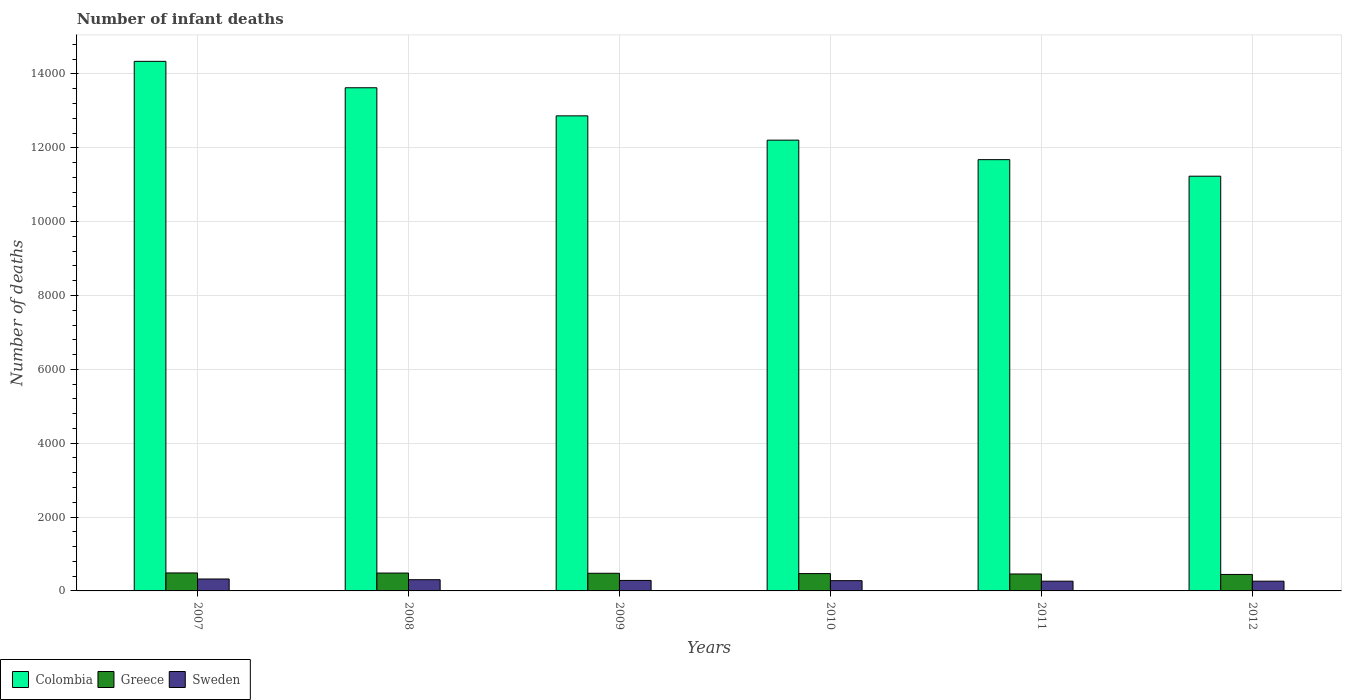What is the label of the 2nd group of bars from the left?
Keep it short and to the point. 2008. In how many cases, is the number of bars for a given year not equal to the number of legend labels?
Provide a succinct answer. 0. What is the number of infant deaths in Greece in 2009?
Ensure brevity in your answer.  478. Across all years, what is the maximum number of infant deaths in Greece?
Offer a very short reply. 487. Across all years, what is the minimum number of infant deaths in Sweden?
Ensure brevity in your answer.  264. What is the total number of infant deaths in Greece in the graph?
Offer a very short reply. 2823. What is the difference between the number of infant deaths in Greece in 2011 and that in 2012?
Keep it short and to the point. 13. What is the difference between the number of infant deaths in Sweden in 2008 and the number of infant deaths in Colombia in 2007?
Keep it short and to the point. -1.40e+04. What is the average number of infant deaths in Greece per year?
Offer a very short reply. 470.5. In the year 2007, what is the difference between the number of infant deaths in Sweden and number of infant deaths in Colombia?
Offer a very short reply. -1.40e+04. What is the ratio of the number of infant deaths in Colombia in 2008 to that in 2010?
Your answer should be compact. 1.12. What is the difference between the highest and the second highest number of infant deaths in Colombia?
Give a very brief answer. 715. What is the difference between the highest and the lowest number of infant deaths in Colombia?
Provide a short and direct response. 3110. In how many years, is the number of infant deaths in Colombia greater than the average number of infant deaths in Colombia taken over all years?
Make the answer very short. 3. What does the 3rd bar from the right in 2012 represents?
Offer a very short reply. Colombia. Is it the case that in every year, the sum of the number of infant deaths in Sweden and number of infant deaths in Greece is greater than the number of infant deaths in Colombia?
Make the answer very short. No. Are all the bars in the graph horizontal?
Ensure brevity in your answer.  No. How many years are there in the graph?
Keep it short and to the point. 6. What is the difference between two consecutive major ticks on the Y-axis?
Keep it short and to the point. 2000. How are the legend labels stacked?
Ensure brevity in your answer.  Horizontal. What is the title of the graph?
Offer a very short reply. Number of infant deaths. Does "Honduras" appear as one of the legend labels in the graph?
Your answer should be very brief. No. What is the label or title of the X-axis?
Ensure brevity in your answer.  Years. What is the label or title of the Y-axis?
Keep it short and to the point. Number of deaths. What is the Number of deaths of Colombia in 2007?
Your response must be concise. 1.43e+04. What is the Number of deaths of Greece in 2007?
Your response must be concise. 487. What is the Number of deaths of Sweden in 2007?
Offer a very short reply. 323. What is the Number of deaths in Colombia in 2008?
Your response must be concise. 1.36e+04. What is the Number of deaths in Greece in 2008?
Give a very brief answer. 484. What is the Number of deaths of Sweden in 2008?
Keep it short and to the point. 304. What is the Number of deaths in Colombia in 2009?
Ensure brevity in your answer.  1.29e+04. What is the Number of deaths in Greece in 2009?
Your response must be concise. 478. What is the Number of deaths in Sweden in 2009?
Your response must be concise. 284. What is the Number of deaths of Colombia in 2010?
Ensure brevity in your answer.  1.22e+04. What is the Number of deaths in Greece in 2010?
Offer a terse response. 469. What is the Number of deaths in Sweden in 2010?
Offer a terse response. 278. What is the Number of deaths in Colombia in 2011?
Offer a very short reply. 1.17e+04. What is the Number of deaths in Greece in 2011?
Keep it short and to the point. 459. What is the Number of deaths of Sweden in 2011?
Your answer should be compact. 264. What is the Number of deaths of Colombia in 2012?
Provide a succinct answer. 1.12e+04. What is the Number of deaths in Greece in 2012?
Your answer should be compact. 446. What is the Number of deaths in Sweden in 2012?
Offer a very short reply. 264. Across all years, what is the maximum Number of deaths of Colombia?
Your answer should be compact. 1.43e+04. Across all years, what is the maximum Number of deaths in Greece?
Make the answer very short. 487. Across all years, what is the maximum Number of deaths in Sweden?
Provide a succinct answer. 323. Across all years, what is the minimum Number of deaths of Colombia?
Provide a succinct answer. 1.12e+04. Across all years, what is the minimum Number of deaths in Greece?
Make the answer very short. 446. Across all years, what is the minimum Number of deaths in Sweden?
Ensure brevity in your answer.  264. What is the total Number of deaths of Colombia in the graph?
Your answer should be compact. 7.60e+04. What is the total Number of deaths in Greece in the graph?
Keep it short and to the point. 2823. What is the total Number of deaths of Sweden in the graph?
Your response must be concise. 1717. What is the difference between the Number of deaths of Colombia in 2007 and that in 2008?
Provide a short and direct response. 715. What is the difference between the Number of deaths in Sweden in 2007 and that in 2008?
Ensure brevity in your answer.  19. What is the difference between the Number of deaths in Colombia in 2007 and that in 2009?
Provide a succinct answer. 1476. What is the difference between the Number of deaths in Colombia in 2007 and that in 2010?
Your answer should be very brief. 2134. What is the difference between the Number of deaths in Colombia in 2007 and that in 2011?
Make the answer very short. 2662. What is the difference between the Number of deaths in Greece in 2007 and that in 2011?
Your response must be concise. 28. What is the difference between the Number of deaths of Colombia in 2007 and that in 2012?
Offer a terse response. 3110. What is the difference between the Number of deaths in Sweden in 2007 and that in 2012?
Your answer should be very brief. 59. What is the difference between the Number of deaths in Colombia in 2008 and that in 2009?
Keep it short and to the point. 761. What is the difference between the Number of deaths in Sweden in 2008 and that in 2009?
Make the answer very short. 20. What is the difference between the Number of deaths in Colombia in 2008 and that in 2010?
Give a very brief answer. 1419. What is the difference between the Number of deaths of Colombia in 2008 and that in 2011?
Offer a very short reply. 1947. What is the difference between the Number of deaths in Greece in 2008 and that in 2011?
Provide a succinct answer. 25. What is the difference between the Number of deaths in Colombia in 2008 and that in 2012?
Offer a terse response. 2395. What is the difference between the Number of deaths in Greece in 2008 and that in 2012?
Your answer should be very brief. 38. What is the difference between the Number of deaths of Colombia in 2009 and that in 2010?
Give a very brief answer. 658. What is the difference between the Number of deaths of Colombia in 2009 and that in 2011?
Keep it short and to the point. 1186. What is the difference between the Number of deaths in Colombia in 2009 and that in 2012?
Offer a very short reply. 1634. What is the difference between the Number of deaths of Greece in 2009 and that in 2012?
Your answer should be compact. 32. What is the difference between the Number of deaths in Colombia in 2010 and that in 2011?
Your answer should be very brief. 528. What is the difference between the Number of deaths in Colombia in 2010 and that in 2012?
Your answer should be compact. 976. What is the difference between the Number of deaths in Sweden in 2010 and that in 2012?
Your answer should be very brief. 14. What is the difference between the Number of deaths of Colombia in 2011 and that in 2012?
Give a very brief answer. 448. What is the difference between the Number of deaths of Greece in 2011 and that in 2012?
Ensure brevity in your answer.  13. What is the difference between the Number of deaths in Colombia in 2007 and the Number of deaths in Greece in 2008?
Offer a terse response. 1.39e+04. What is the difference between the Number of deaths of Colombia in 2007 and the Number of deaths of Sweden in 2008?
Provide a short and direct response. 1.40e+04. What is the difference between the Number of deaths in Greece in 2007 and the Number of deaths in Sweden in 2008?
Keep it short and to the point. 183. What is the difference between the Number of deaths of Colombia in 2007 and the Number of deaths of Greece in 2009?
Give a very brief answer. 1.39e+04. What is the difference between the Number of deaths of Colombia in 2007 and the Number of deaths of Sweden in 2009?
Provide a short and direct response. 1.41e+04. What is the difference between the Number of deaths of Greece in 2007 and the Number of deaths of Sweden in 2009?
Your response must be concise. 203. What is the difference between the Number of deaths of Colombia in 2007 and the Number of deaths of Greece in 2010?
Keep it short and to the point. 1.39e+04. What is the difference between the Number of deaths in Colombia in 2007 and the Number of deaths in Sweden in 2010?
Your response must be concise. 1.41e+04. What is the difference between the Number of deaths in Greece in 2007 and the Number of deaths in Sweden in 2010?
Your answer should be compact. 209. What is the difference between the Number of deaths of Colombia in 2007 and the Number of deaths of Greece in 2011?
Give a very brief answer. 1.39e+04. What is the difference between the Number of deaths in Colombia in 2007 and the Number of deaths in Sweden in 2011?
Your response must be concise. 1.41e+04. What is the difference between the Number of deaths in Greece in 2007 and the Number of deaths in Sweden in 2011?
Offer a very short reply. 223. What is the difference between the Number of deaths of Colombia in 2007 and the Number of deaths of Greece in 2012?
Make the answer very short. 1.39e+04. What is the difference between the Number of deaths of Colombia in 2007 and the Number of deaths of Sweden in 2012?
Offer a terse response. 1.41e+04. What is the difference between the Number of deaths of Greece in 2007 and the Number of deaths of Sweden in 2012?
Keep it short and to the point. 223. What is the difference between the Number of deaths in Colombia in 2008 and the Number of deaths in Greece in 2009?
Provide a succinct answer. 1.31e+04. What is the difference between the Number of deaths in Colombia in 2008 and the Number of deaths in Sweden in 2009?
Your answer should be compact. 1.33e+04. What is the difference between the Number of deaths of Colombia in 2008 and the Number of deaths of Greece in 2010?
Your answer should be very brief. 1.32e+04. What is the difference between the Number of deaths of Colombia in 2008 and the Number of deaths of Sweden in 2010?
Your response must be concise. 1.33e+04. What is the difference between the Number of deaths of Greece in 2008 and the Number of deaths of Sweden in 2010?
Make the answer very short. 206. What is the difference between the Number of deaths in Colombia in 2008 and the Number of deaths in Greece in 2011?
Offer a terse response. 1.32e+04. What is the difference between the Number of deaths of Colombia in 2008 and the Number of deaths of Sweden in 2011?
Make the answer very short. 1.34e+04. What is the difference between the Number of deaths in Greece in 2008 and the Number of deaths in Sweden in 2011?
Provide a succinct answer. 220. What is the difference between the Number of deaths in Colombia in 2008 and the Number of deaths in Greece in 2012?
Give a very brief answer. 1.32e+04. What is the difference between the Number of deaths of Colombia in 2008 and the Number of deaths of Sweden in 2012?
Provide a succinct answer. 1.34e+04. What is the difference between the Number of deaths in Greece in 2008 and the Number of deaths in Sweden in 2012?
Offer a very short reply. 220. What is the difference between the Number of deaths in Colombia in 2009 and the Number of deaths in Greece in 2010?
Offer a very short reply. 1.24e+04. What is the difference between the Number of deaths in Colombia in 2009 and the Number of deaths in Sweden in 2010?
Provide a short and direct response. 1.26e+04. What is the difference between the Number of deaths in Greece in 2009 and the Number of deaths in Sweden in 2010?
Ensure brevity in your answer.  200. What is the difference between the Number of deaths of Colombia in 2009 and the Number of deaths of Greece in 2011?
Offer a terse response. 1.24e+04. What is the difference between the Number of deaths of Colombia in 2009 and the Number of deaths of Sweden in 2011?
Offer a terse response. 1.26e+04. What is the difference between the Number of deaths of Greece in 2009 and the Number of deaths of Sweden in 2011?
Provide a short and direct response. 214. What is the difference between the Number of deaths of Colombia in 2009 and the Number of deaths of Greece in 2012?
Provide a succinct answer. 1.24e+04. What is the difference between the Number of deaths in Colombia in 2009 and the Number of deaths in Sweden in 2012?
Make the answer very short. 1.26e+04. What is the difference between the Number of deaths in Greece in 2009 and the Number of deaths in Sweden in 2012?
Keep it short and to the point. 214. What is the difference between the Number of deaths of Colombia in 2010 and the Number of deaths of Greece in 2011?
Your answer should be compact. 1.17e+04. What is the difference between the Number of deaths in Colombia in 2010 and the Number of deaths in Sweden in 2011?
Give a very brief answer. 1.19e+04. What is the difference between the Number of deaths in Greece in 2010 and the Number of deaths in Sweden in 2011?
Make the answer very short. 205. What is the difference between the Number of deaths in Colombia in 2010 and the Number of deaths in Greece in 2012?
Offer a terse response. 1.18e+04. What is the difference between the Number of deaths of Colombia in 2010 and the Number of deaths of Sweden in 2012?
Make the answer very short. 1.19e+04. What is the difference between the Number of deaths in Greece in 2010 and the Number of deaths in Sweden in 2012?
Your answer should be compact. 205. What is the difference between the Number of deaths of Colombia in 2011 and the Number of deaths of Greece in 2012?
Keep it short and to the point. 1.12e+04. What is the difference between the Number of deaths in Colombia in 2011 and the Number of deaths in Sweden in 2012?
Give a very brief answer. 1.14e+04. What is the difference between the Number of deaths in Greece in 2011 and the Number of deaths in Sweden in 2012?
Offer a terse response. 195. What is the average Number of deaths in Colombia per year?
Your answer should be compact. 1.27e+04. What is the average Number of deaths in Greece per year?
Provide a succinct answer. 470.5. What is the average Number of deaths of Sweden per year?
Make the answer very short. 286.17. In the year 2007, what is the difference between the Number of deaths in Colombia and Number of deaths in Greece?
Your response must be concise. 1.39e+04. In the year 2007, what is the difference between the Number of deaths of Colombia and Number of deaths of Sweden?
Your answer should be very brief. 1.40e+04. In the year 2007, what is the difference between the Number of deaths in Greece and Number of deaths in Sweden?
Provide a short and direct response. 164. In the year 2008, what is the difference between the Number of deaths in Colombia and Number of deaths in Greece?
Your response must be concise. 1.31e+04. In the year 2008, what is the difference between the Number of deaths in Colombia and Number of deaths in Sweden?
Your answer should be very brief. 1.33e+04. In the year 2008, what is the difference between the Number of deaths in Greece and Number of deaths in Sweden?
Your answer should be compact. 180. In the year 2009, what is the difference between the Number of deaths of Colombia and Number of deaths of Greece?
Offer a terse response. 1.24e+04. In the year 2009, what is the difference between the Number of deaths in Colombia and Number of deaths in Sweden?
Make the answer very short. 1.26e+04. In the year 2009, what is the difference between the Number of deaths in Greece and Number of deaths in Sweden?
Your answer should be compact. 194. In the year 2010, what is the difference between the Number of deaths of Colombia and Number of deaths of Greece?
Make the answer very short. 1.17e+04. In the year 2010, what is the difference between the Number of deaths in Colombia and Number of deaths in Sweden?
Provide a short and direct response. 1.19e+04. In the year 2010, what is the difference between the Number of deaths of Greece and Number of deaths of Sweden?
Make the answer very short. 191. In the year 2011, what is the difference between the Number of deaths of Colombia and Number of deaths of Greece?
Make the answer very short. 1.12e+04. In the year 2011, what is the difference between the Number of deaths in Colombia and Number of deaths in Sweden?
Ensure brevity in your answer.  1.14e+04. In the year 2011, what is the difference between the Number of deaths of Greece and Number of deaths of Sweden?
Provide a short and direct response. 195. In the year 2012, what is the difference between the Number of deaths in Colombia and Number of deaths in Greece?
Your response must be concise. 1.08e+04. In the year 2012, what is the difference between the Number of deaths in Colombia and Number of deaths in Sweden?
Provide a short and direct response. 1.10e+04. In the year 2012, what is the difference between the Number of deaths in Greece and Number of deaths in Sweden?
Keep it short and to the point. 182. What is the ratio of the Number of deaths of Colombia in 2007 to that in 2008?
Your answer should be very brief. 1.05. What is the ratio of the Number of deaths in Sweden in 2007 to that in 2008?
Your answer should be compact. 1.06. What is the ratio of the Number of deaths of Colombia in 2007 to that in 2009?
Ensure brevity in your answer.  1.11. What is the ratio of the Number of deaths in Greece in 2007 to that in 2009?
Provide a short and direct response. 1.02. What is the ratio of the Number of deaths of Sweden in 2007 to that in 2009?
Your response must be concise. 1.14. What is the ratio of the Number of deaths in Colombia in 2007 to that in 2010?
Provide a succinct answer. 1.17. What is the ratio of the Number of deaths of Greece in 2007 to that in 2010?
Make the answer very short. 1.04. What is the ratio of the Number of deaths in Sweden in 2007 to that in 2010?
Make the answer very short. 1.16. What is the ratio of the Number of deaths in Colombia in 2007 to that in 2011?
Provide a short and direct response. 1.23. What is the ratio of the Number of deaths of Greece in 2007 to that in 2011?
Ensure brevity in your answer.  1.06. What is the ratio of the Number of deaths in Sweden in 2007 to that in 2011?
Offer a terse response. 1.22. What is the ratio of the Number of deaths of Colombia in 2007 to that in 2012?
Ensure brevity in your answer.  1.28. What is the ratio of the Number of deaths in Greece in 2007 to that in 2012?
Offer a very short reply. 1.09. What is the ratio of the Number of deaths in Sweden in 2007 to that in 2012?
Your response must be concise. 1.22. What is the ratio of the Number of deaths in Colombia in 2008 to that in 2009?
Provide a succinct answer. 1.06. What is the ratio of the Number of deaths of Greece in 2008 to that in 2009?
Your response must be concise. 1.01. What is the ratio of the Number of deaths in Sweden in 2008 to that in 2009?
Provide a short and direct response. 1.07. What is the ratio of the Number of deaths of Colombia in 2008 to that in 2010?
Provide a succinct answer. 1.12. What is the ratio of the Number of deaths in Greece in 2008 to that in 2010?
Offer a very short reply. 1.03. What is the ratio of the Number of deaths in Sweden in 2008 to that in 2010?
Ensure brevity in your answer.  1.09. What is the ratio of the Number of deaths in Greece in 2008 to that in 2011?
Provide a succinct answer. 1.05. What is the ratio of the Number of deaths of Sweden in 2008 to that in 2011?
Your answer should be very brief. 1.15. What is the ratio of the Number of deaths in Colombia in 2008 to that in 2012?
Make the answer very short. 1.21. What is the ratio of the Number of deaths in Greece in 2008 to that in 2012?
Your answer should be very brief. 1.09. What is the ratio of the Number of deaths in Sweden in 2008 to that in 2012?
Make the answer very short. 1.15. What is the ratio of the Number of deaths in Colombia in 2009 to that in 2010?
Your answer should be compact. 1.05. What is the ratio of the Number of deaths in Greece in 2009 to that in 2010?
Provide a succinct answer. 1.02. What is the ratio of the Number of deaths of Sweden in 2009 to that in 2010?
Give a very brief answer. 1.02. What is the ratio of the Number of deaths in Colombia in 2009 to that in 2011?
Make the answer very short. 1.1. What is the ratio of the Number of deaths of Greece in 2009 to that in 2011?
Give a very brief answer. 1.04. What is the ratio of the Number of deaths of Sweden in 2009 to that in 2011?
Ensure brevity in your answer.  1.08. What is the ratio of the Number of deaths in Colombia in 2009 to that in 2012?
Offer a terse response. 1.15. What is the ratio of the Number of deaths in Greece in 2009 to that in 2012?
Give a very brief answer. 1.07. What is the ratio of the Number of deaths in Sweden in 2009 to that in 2012?
Offer a terse response. 1.08. What is the ratio of the Number of deaths of Colombia in 2010 to that in 2011?
Your response must be concise. 1.05. What is the ratio of the Number of deaths of Greece in 2010 to that in 2011?
Provide a succinct answer. 1.02. What is the ratio of the Number of deaths of Sweden in 2010 to that in 2011?
Your answer should be very brief. 1.05. What is the ratio of the Number of deaths of Colombia in 2010 to that in 2012?
Offer a very short reply. 1.09. What is the ratio of the Number of deaths in Greece in 2010 to that in 2012?
Your answer should be very brief. 1.05. What is the ratio of the Number of deaths of Sweden in 2010 to that in 2012?
Your response must be concise. 1.05. What is the ratio of the Number of deaths of Colombia in 2011 to that in 2012?
Offer a terse response. 1.04. What is the ratio of the Number of deaths of Greece in 2011 to that in 2012?
Provide a succinct answer. 1.03. What is the difference between the highest and the second highest Number of deaths of Colombia?
Ensure brevity in your answer.  715. What is the difference between the highest and the second highest Number of deaths of Sweden?
Your response must be concise. 19. What is the difference between the highest and the lowest Number of deaths of Colombia?
Give a very brief answer. 3110. What is the difference between the highest and the lowest Number of deaths of Sweden?
Give a very brief answer. 59. 